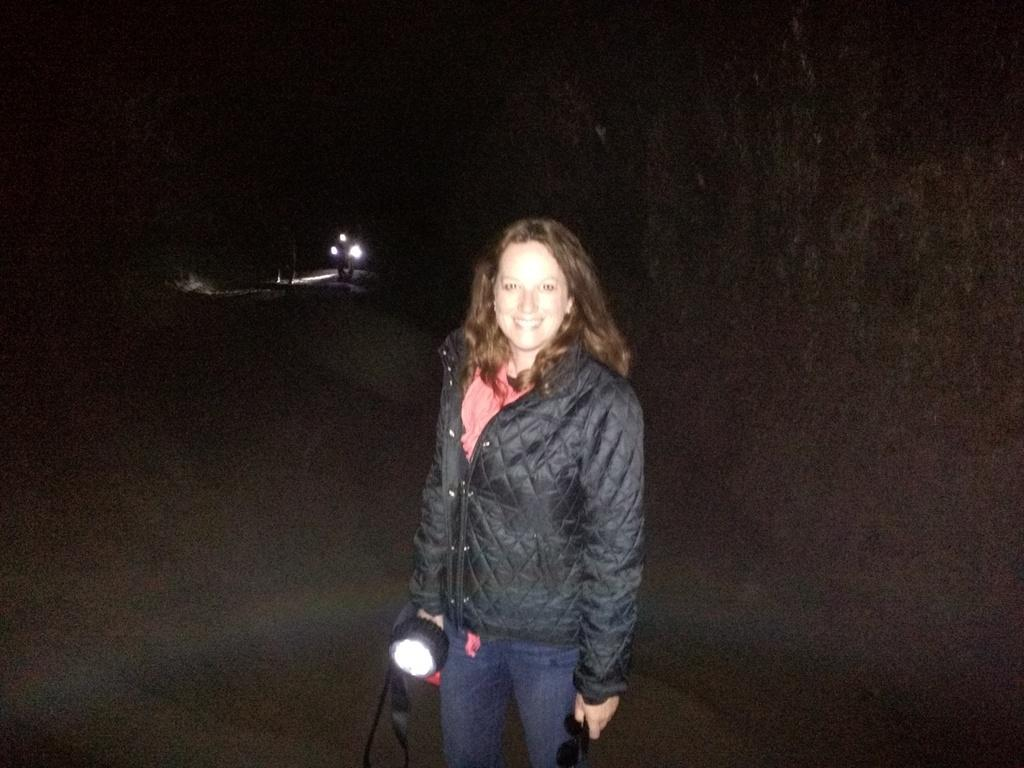What is the person in the image doing? The person is standing in the image and holding a torch. What is the person wearing in the image? The person is wearing a black color jacket. What can be seen in the background of the image? There are lights visible in the background of the image. What type of humor can be seen in the person's facial expression in the image? There is no indication of humor or facial expression in the image, as it only shows a person holding a torch and wearing a black jacket. 